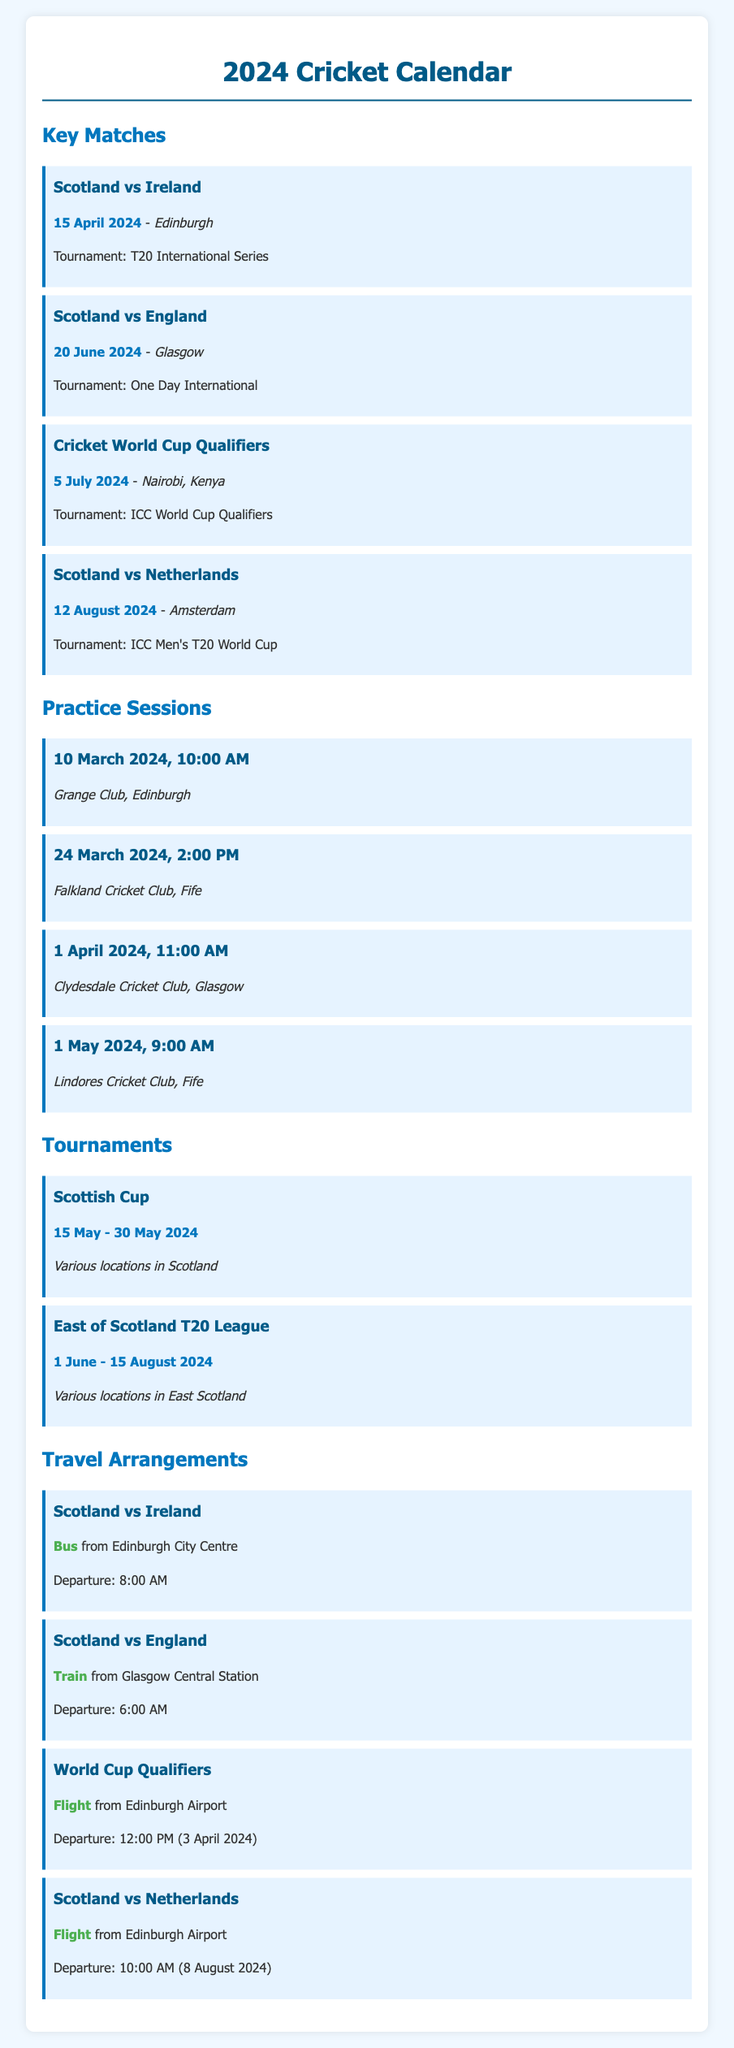What is the date of the match between Scotland and Ireland? The date of the match between Scotland and Ireland is specifically noted in the document as April 15, 2024.
Answer: 15 April 2024 Where will the ICC World Cup Qualifiers be held? The location for the ICC World Cup Qualifiers is explicitly mentioned as Nairobi, Kenya in the document.
Answer: Nairobi, Kenya What is the time for the practice session on 1 April 2024? The time for the practice session on 1 April 2024 is detailed in the document as 11:00 AM.
Answer: 11:00 AM How will the team travel for the match against England? The travel method for the match against England is found in the document, which states it is by train.
Answer: Train During which month is the Scottish Cup scheduled? The Scottish Cup is scheduled to take place from May 15 to May 30, 2024, indicating that it occurs in May.
Answer: May What location is specified for the practice session on 10 March 2024? The location for the practice session on 10 March 2024 is clearly stated as Grange Club, Edinburgh.
Answer: Grange Club, Edinburgh How many practice sessions are listed before the first match? The document lists a total of four practice sessions before the first match against Ireland.
Answer: 4 What is the departure time for the flight to the World Cup Qualifiers? The departure time for the flight to the World Cup Qualifiers is noted as 12:00 PM on April 3, 2024, in the document.
Answer: 12:00 PM (3 April 2024) Which tournament occurs from June 1 to August 15, 2024? The tournament that occurs during this period is specified in the document as the East of Scotland T20 League.
Answer: East of Scotland T20 League 